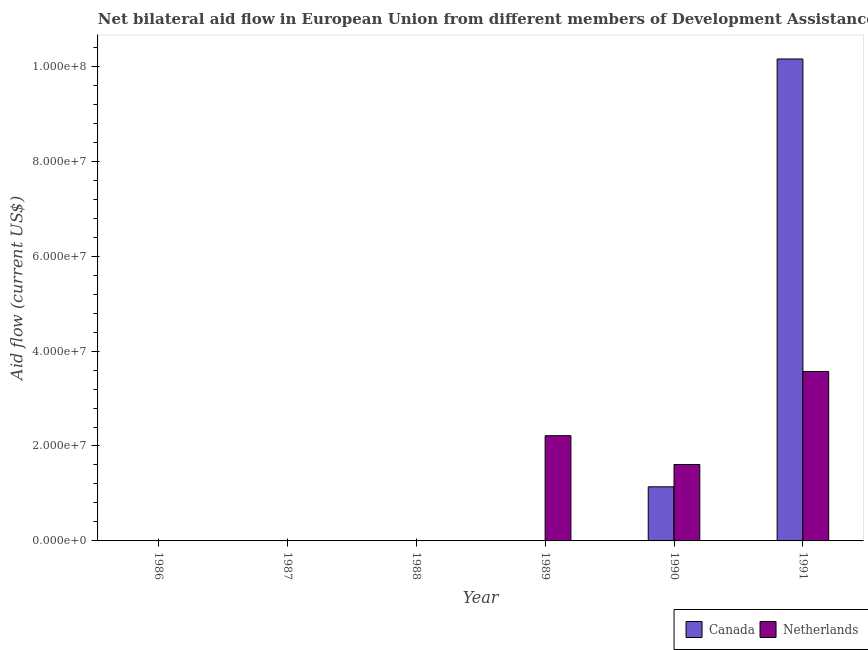How many bars are there on the 4th tick from the left?
Your answer should be very brief. 1. What is the label of the 6th group of bars from the left?
Make the answer very short. 1991. In how many cases, is the number of bars for a given year not equal to the number of legend labels?
Your response must be concise. 4. What is the amount of aid given by canada in 1991?
Make the answer very short. 1.02e+08. Across all years, what is the maximum amount of aid given by netherlands?
Keep it short and to the point. 3.57e+07. Across all years, what is the minimum amount of aid given by netherlands?
Your answer should be very brief. 0. In which year was the amount of aid given by netherlands maximum?
Your response must be concise. 1991. What is the total amount of aid given by netherlands in the graph?
Make the answer very short. 7.40e+07. What is the difference between the amount of aid given by canada in 1986 and that in 1991?
Keep it short and to the point. -1.02e+08. What is the difference between the amount of aid given by netherlands in 1990 and the amount of aid given by canada in 1989?
Offer a terse response. -6.07e+06. What is the average amount of aid given by canada per year?
Ensure brevity in your answer.  1.88e+07. In the year 1989, what is the difference between the amount of aid given by netherlands and amount of aid given by canada?
Your response must be concise. 0. In how many years, is the amount of aid given by canada greater than 36000000 US$?
Make the answer very short. 1. What is the ratio of the amount of aid given by canada in 1986 to that in 1988?
Your response must be concise. 0.25. Is the difference between the amount of aid given by canada in 1988 and 1990 greater than the difference between the amount of aid given by netherlands in 1988 and 1990?
Provide a short and direct response. No. What is the difference between the highest and the second highest amount of aid given by canada?
Ensure brevity in your answer.  9.01e+07. What is the difference between the highest and the lowest amount of aid given by canada?
Offer a very short reply. 1.02e+08. How many years are there in the graph?
Give a very brief answer. 6. Are the values on the major ticks of Y-axis written in scientific E-notation?
Your response must be concise. Yes. Does the graph contain grids?
Your answer should be compact. No. How are the legend labels stacked?
Offer a very short reply. Horizontal. What is the title of the graph?
Make the answer very short. Net bilateral aid flow in European Union from different members of Development Assistance Committee. What is the label or title of the X-axis?
Provide a succinct answer. Year. What is the label or title of the Y-axis?
Keep it short and to the point. Aid flow (current US$). What is the Aid flow (current US$) of Netherlands in 1986?
Your answer should be compact. 0. What is the Aid flow (current US$) in Canada in 1987?
Ensure brevity in your answer.  2.00e+04. What is the Aid flow (current US$) in Netherlands in 1987?
Offer a very short reply. 0. What is the Aid flow (current US$) of Canada in 1988?
Offer a terse response. 4.00e+04. What is the Aid flow (current US$) of Canada in 1989?
Your response must be concise. 0. What is the Aid flow (current US$) of Netherlands in 1989?
Offer a very short reply. 2.22e+07. What is the Aid flow (current US$) of Canada in 1990?
Keep it short and to the point. 1.14e+07. What is the Aid flow (current US$) in Netherlands in 1990?
Keep it short and to the point. 1.61e+07. What is the Aid flow (current US$) of Canada in 1991?
Ensure brevity in your answer.  1.02e+08. What is the Aid flow (current US$) of Netherlands in 1991?
Your response must be concise. 3.57e+07. Across all years, what is the maximum Aid flow (current US$) in Canada?
Offer a very short reply. 1.02e+08. Across all years, what is the maximum Aid flow (current US$) of Netherlands?
Offer a terse response. 3.57e+07. Across all years, what is the minimum Aid flow (current US$) in Canada?
Your answer should be very brief. 0. Across all years, what is the minimum Aid flow (current US$) in Netherlands?
Keep it short and to the point. 0. What is the total Aid flow (current US$) in Canada in the graph?
Provide a succinct answer. 1.13e+08. What is the total Aid flow (current US$) of Netherlands in the graph?
Ensure brevity in your answer.  7.40e+07. What is the difference between the Aid flow (current US$) of Canada in 1986 and that in 1987?
Offer a terse response. -10000. What is the difference between the Aid flow (current US$) of Canada in 1986 and that in 1990?
Provide a succinct answer. -1.14e+07. What is the difference between the Aid flow (current US$) in Canada in 1986 and that in 1991?
Offer a terse response. -1.02e+08. What is the difference between the Aid flow (current US$) in Canada in 1987 and that in 1988?
Your answer should be compact. -2.00e+04. What is the difference between the Aid flow (current US$) in Canada in 1987 and that in 1990?
Your answer should be very brief. -1.14e+07. What is the difference between the Aid flow (current US$) in Canada in 1987 and that in 1991?
Your response must be concise. -1.02e+08. What is the difference between the Aid flow (current US$) of Canada in 1988 and that in 1990?
Your answer should be compact. -1.14e+07. What is the difference between the Aid flow (current US$) in Canada in 1988 and that in 1991?
Give a very brief answer. -1.02e+08. What is the difference between the Aid flow (current US$) in Netherlands in 1989 and that in 1990?
Keep it short and to the point. 6.07e+06. What is the difference between the Aid flow (current US$) of Netherlands in 1989 and that in 1991?
Give a very brief answer. -1.35e+07. What is the difference between the Aid flow (current US$) of Canada in 1990 and that in 1991?
Your answer should be compact. -9.01e+07. What is the difference between the Aid flow (current US$) of Netherlands in 1990 and that in 1991?
Offer a very short reply. -1.96e+07. What is the difference between the Aid flow (current US$) of Canada in 1986 and the Aid flow (current US$) of Netherlands in 1989?
Ensure brevity in your answer.  -2.22e+07. What is the difference between the Aid flow (current US$) in Canada in 1986 and the Aid flow (current US$) in Netherlands in 1990?
Keep it short and to the point. -1.61e+07. What is the difference between the Aid flow (current US$) in Canada in 1986 and the Aid flow (current US$) in Netherlands in 1991?
Make the answer very short. -3.57e+07. What is the difference between the Aid flow (current US$) of Canada in 1987 and the Aid flow (current US$) of Netherlands in 1989?
Offer a terse response. -2.22e+07. What is the difference between the Aid flow (current US$) of Canada in 1987 and the Aid flow (current US$) of Netherlands in 1990?
Offer a very short reply. -1.61e+07. What is the difference between the Aid flow (current US$) in Canada in 1987 and the Aid flow (current US$) in Netherlands in 1991?
Keep it short and to the point. -3.57e+07. What is the difference between the Aid flow (current US$) of Canada in 1988 and the Aid flow (current US$) of Netherlands in 1989?
Make the answer very short. -2.21e+07. What is the difference between the Aid flow (current US$) in Canada in 1988 and the Aid flow (current US$) in Netherlands in 1990?
Make the answer very short. -1.61e+07. What is the difference between the Aid flow (current US$) of Canada in 1988 and the Aid flow (current US$) of Netherlands in 1991?
Provide a short and direct response. -3.56e+07. What is the difference between the Aid flow (current US$) of Canada in 1990 and the Aid flow (current US$) of Netherlands in 1991?
Provide a short and direct response. -2.43e+07. What is the average Aid flow (current US$) in Canada per year?
Your response must be concise. 1.88e+07. What is the average Aid flow (current US$) of Netherlands per year?
Ensure brevity in your answer.  1.23e+07. In the year 1990, what is the difference between the Aid flow (current US$) in Canada and Aid flow (current US$) in Netherlands?
Provide a short and direct response. -4.70e+06. In the year 1991, what is the difference between the Aid flow (current US$) of Canada and Aid flow (current US$) of Netherlands?
Ensure brevity in your answer.  6.59e+07. What is the ratio of the Aid flow (current US$) in Canada in 1986 to that in 1987?
Offer a terse response. 0.5. What is the ratio of the Aid flow (current US$) of Canada in 1986 to that in 1988?
Your answer should be compact. 0.25. What is the ratio of the Aid flow (current US$) in Canada in 1986 to that in 1990?
Keep it short and to the point. 0. What is the ratio of the Aid flow (current US$) of Canada in 1987 to that in 1990?
Your answer should be compact. 0. What is the ratio of the Aid flow (current US$) in Canada in 1988 to that in 1990?
Offer a very short reply. 0. What is the ratio of the Aid flow (current US$) in Canada in 1988 to that in 1991?
Your answer should be compact. 0. What is the ratio of the Aid flow (current US$) of Netherlands in 1989 to that in 1990?
Provide a short and direct response. 1.38. What is the ratio of the Aid flow (current US$) of Netherlands in 1989 to that in 1991?
Provide a succinct answer. 0.62. What is the ratio of the Aid flow (current US$) of Canada in 1990 to that in 1991?
Offer a very short reply. 0.11. What is the ratio of the Aid flow (current US$) in Netherlands in 1990 to that in 1991?
Provide a succinct answer. 0.45. What is the difference between the highest and the second highest Aid flow (current US$) of Canada?
Provide a succinct answer. 9.01e+07. What is the difference between the highest and the second highest Aid flow (current US$) in Netherlands?
Offer a terse response. 1.35e+07. What is the difference between the highest and the lowest Aid flow (current US$) of Canada?
Offer a very short reply. 1.02e+08. What is the difference between the highest and the lowest Aid flow (current US$) of Netherlands?
Make the answer very short. 3.57e+07. 